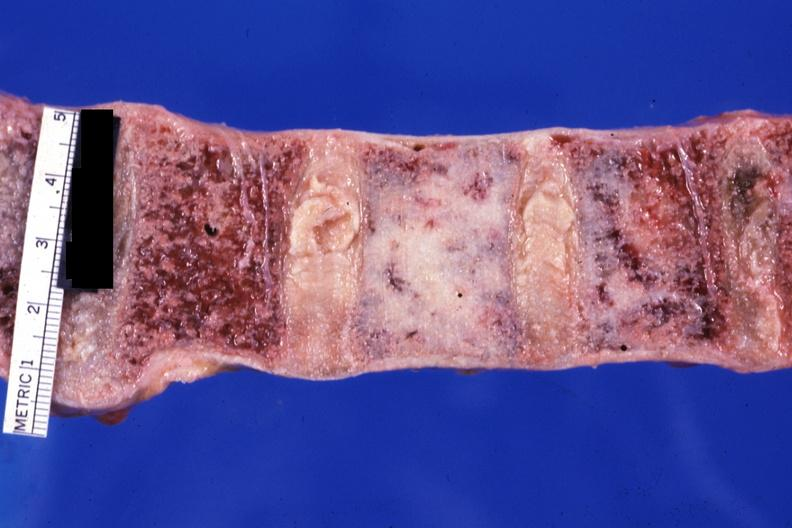does this image show close-up looks like ivory vertebra of breast carcinoma?
Answer the question using a single word or phrase. Yes 